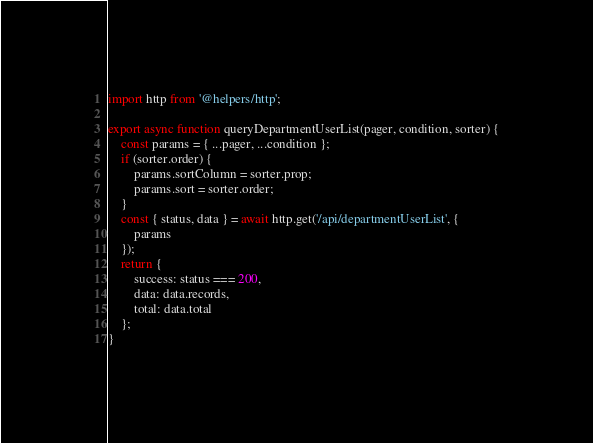<code> <loc_0><loc_0><loc_500><loc_500><_JavaScript_>import http from '@helpers/http';

export async function queryDepartmentUserList(pager, condition, sorter) {
    const params = { ...pager, ...condition };
    if (sorter.order) {
        params.sortColumn = sorter.prop;
        params.sort = sorter.order;
    }
    const { status, data } = await http.get('/api/departmentUserList', {
        params
    });
    return {
        success: status === 200,
        data: data.records,
        total: data.total
    };
}
</code> 